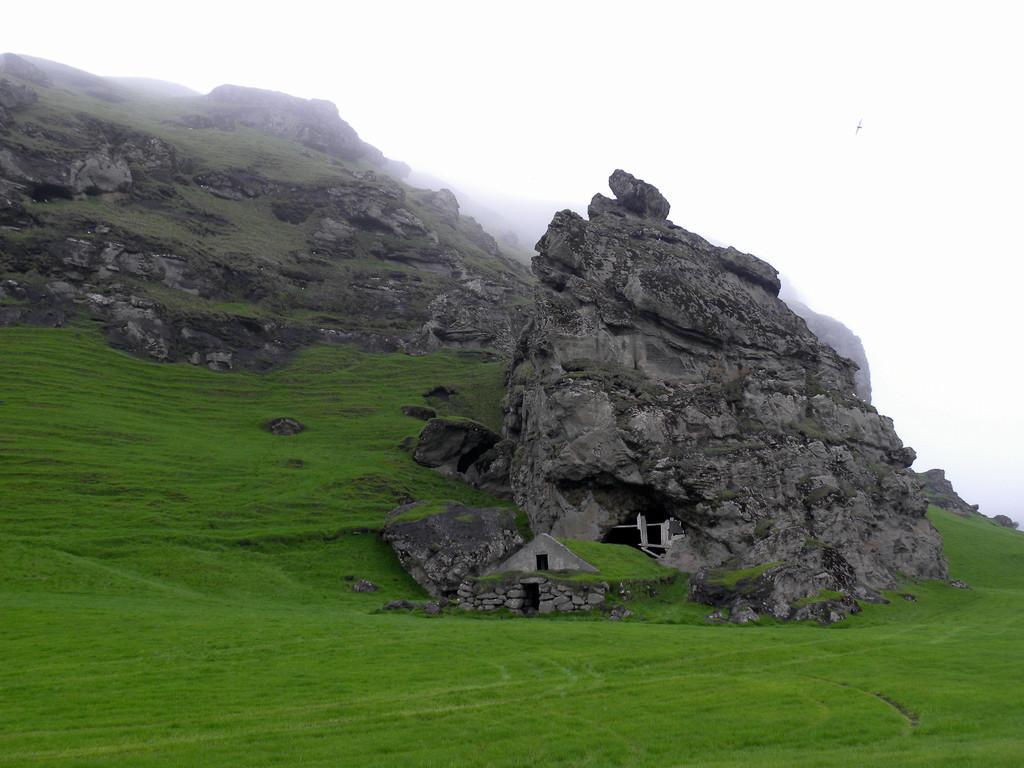Can you describe this image briefly? This picture might be taken outside of the city. In this image, in the middle, we can see some rocks and a cave. On the left side, we can also see some rocks. In the background, we can also see white color, at the bottom there is a grass. 